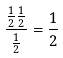<formula> <loc_0><loc_0><loc_500><loc_500>\frac { \frac { 1 } { 2 } \frac { 1 } { 2 } } { \frac { 1 } { 2 } } = \frac { 1 } { 2 }</formula> 